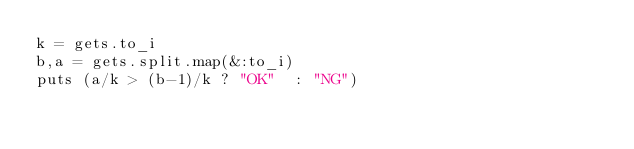<code> <loc_0><loc_0><loc_500><loc_500><_Ruby_>k = gets.to_i
b,a = gets.split.map(&:to_i)
puts (a/k > (b-1)/k ? "OK"  : "NG")</code> 